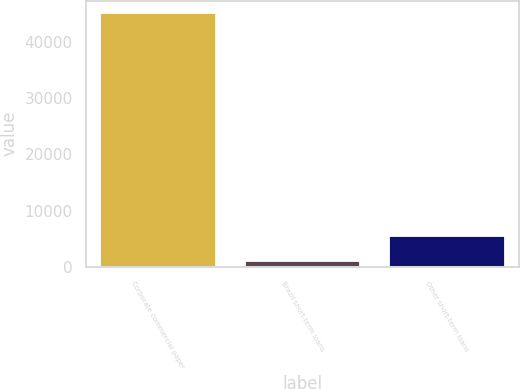<chart> <loc_0><loc_0><loc_500><loc_500><bar_chart><fcel>Corporate commercial paper<fcel>Brazil short-term loans<fcel>Other short-term loans<nl><fcel>45000<fcel>1000<fcel>5400<nl></chart> 